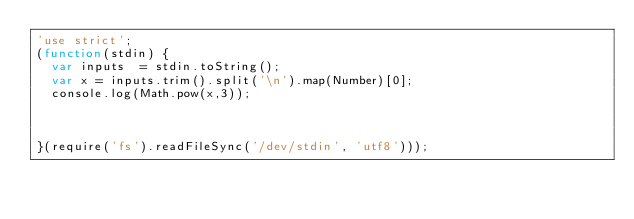Convert code to text. <code><loc_0><loc_0><loc_500><loc_500><_JavaScript_>'use strict';
(function(stdin) {
  var inputs  = stdin.toString();
  var x = inputs.trim().split('\n').map(Number)[0];
  console.log(Math.pow(x,3));



}(require('fs').readFileSync('/dev/stdin', 'utf8')));</code> 